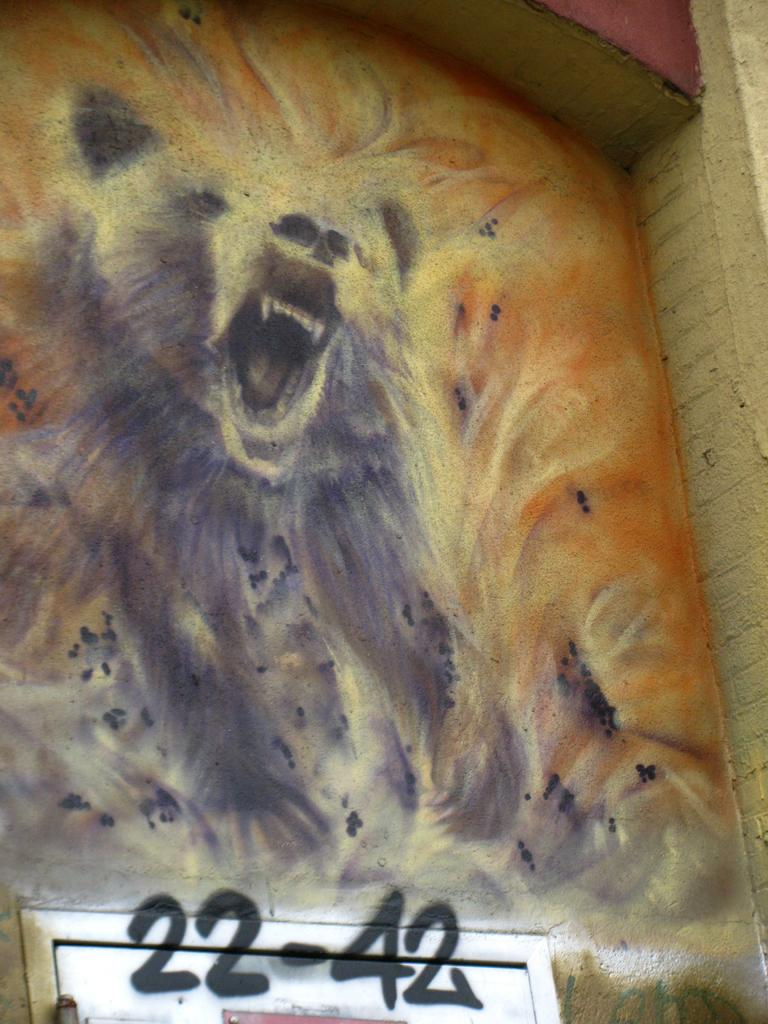What is depicted on the wall in the image? There is a painting of an animal on the wall. What color is the animal in the painting? The animal in the painting is black. What color is the wall on which the painting is hung? The wall is cream-colored. Is there any text or writing present in the image? Yes, there is text or writing on the image. What type of quilt is being used to cover the animal in the painting? There is no quilt present in the image; it is a painting of an animal on a wall. What language is spoken by the animal in the painting? The painting is a still image and does not depict the animal speaking any language. 